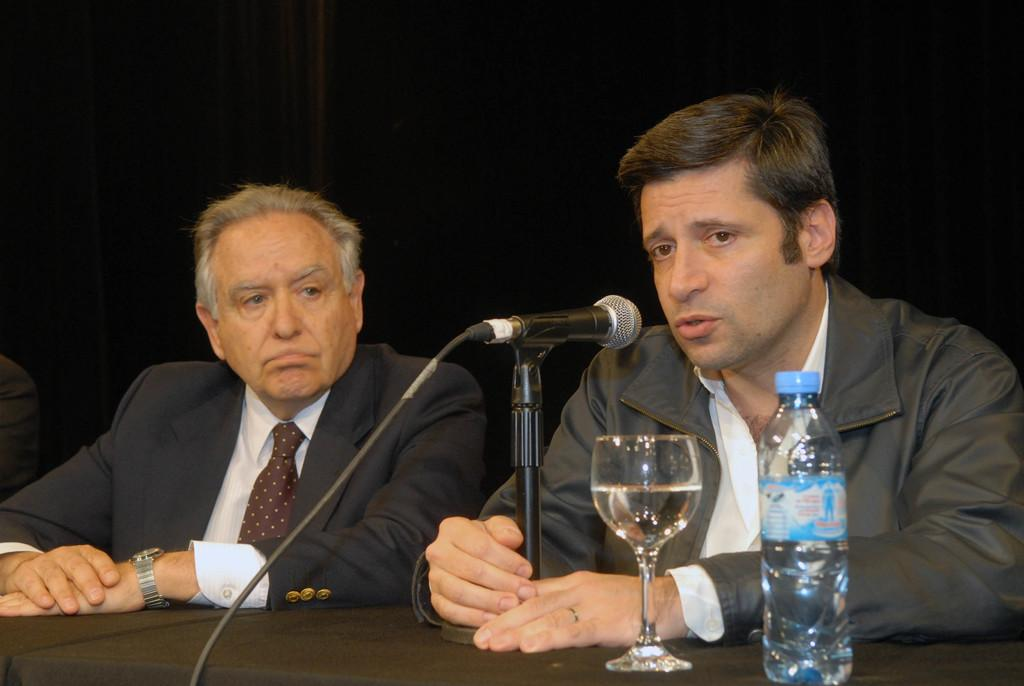How many people are in the image? There are two persons in the image. What is the person on the right wearing? The person on the right is wearing a black jacket. What is the person in the black jacket holding? The person in the black jacket is holding a mic. Where is the person in the black jacket located in the image? The person in the black jacket is in the right corner of the image. What objects can be seen on the table in the image? There is a glass and a bottle on the table in the image. Can you see a bag on the person's head in the image? No, there is no bag on anyone's head in the image. Is there a man wearing a crown in the image? No, there is no man wearing a crown in the image. 